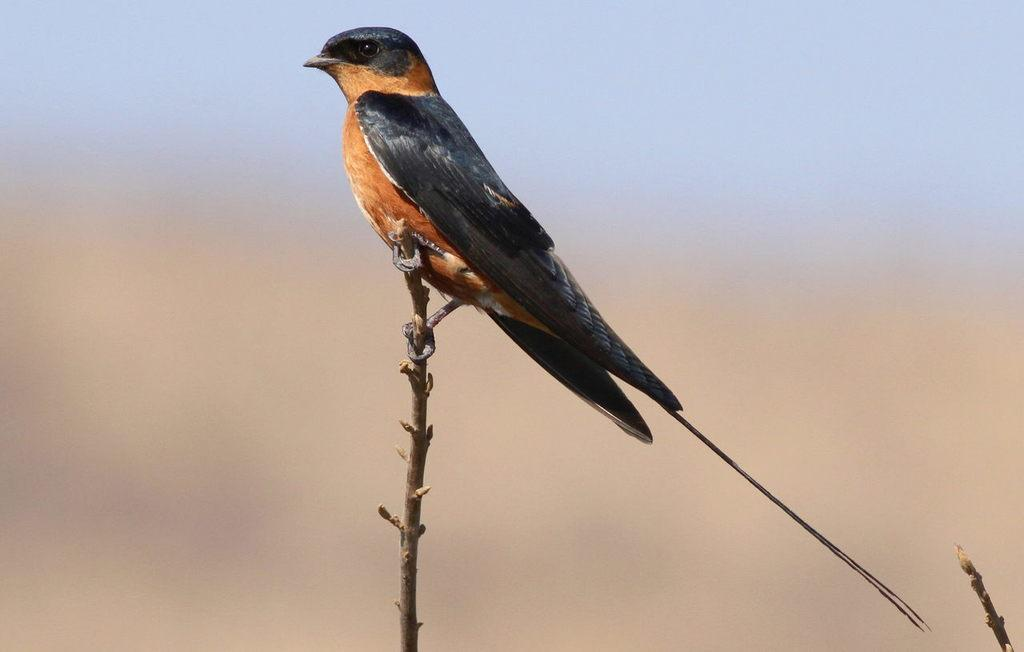What type of animal is in the image? There is a bird in the image. Where is the bird located? The bird is on a branch. What can be seen in the background of the image? The background of the image is blurry, but the sky is visible. What type of pet does the bird have in the image? There is no pet present in the image; it features a bird on a branch with a blurry background and the sky visible. 